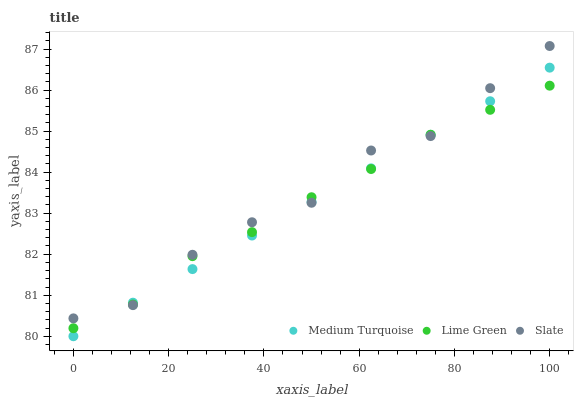Does Medium Turquoise have the minimum area under the curve?
Answer yes or no. Yes. Does Slate have the maximum area under the curve?
Answer yes or no. Yes. Does Lime Green have the minimum area under the curve?
Answer yes or no. No. Does Lime Green have the maximum area under the curve?
Answer yes or no. No. Is Medium Turquoise the smoothest?
Answer yes or no. Yes. Is Slate the roughest?
Answer yes or no. Yes. Is Lime Green the smoothest?
Answer yes or no. No. Is Lime Green the roughest?
Answer yes or no. No. Does Medium Turquoise have the lowest value?
Answer yes or no. Yes. Does Lime Green have the lowest value?
Answer yes or no. No. Does Slate have the highest value?
Answer yes or no. Yes. Does Medium Turquoise have the highest value?
Answer yes or no. No. Does Lime Green intersect Medium Turquoise?
Answer yes or no. Yes. Is Lime Green less than Medium Turquoise?
Answer yes or no. No. Is Lime Green greater than Medium Turquoise?
Answer yes or no. No. 